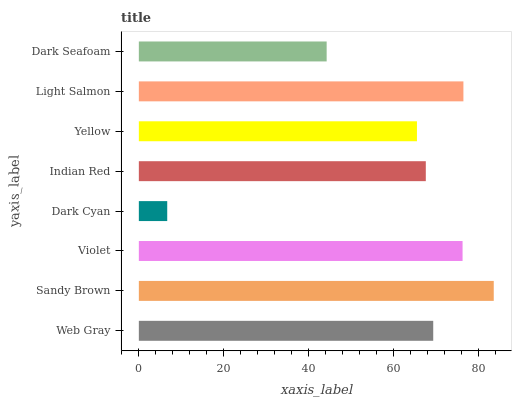Is Dark Cyan the minimum?
Answer yes or no. Yes. Is Sandy Brown the maximum?
Answer yes or no. Yes. Is Violet the minimum?
Answer yes or no. No. Is Violet the maximum?
Answer yes or no. No. Is Sandy Brown greater than Violet?
Answer yes or no. Yes. Is Violet less than Sandy Brown?
Answer yes or no. Yes. Is Violet greater than Sandy Brown?
Answer yes or no. No. Is Sandy Brown less than Violet?
Answer yes or no. No. Is Web Gray the high median?
Answer yes or no. Yes. Is Indian Red the low median?
Answer yes or no. Yes. Is Violet the high median?
Answer yes or no. No. Is Yellow the low median?
Answer yes or no. No. 